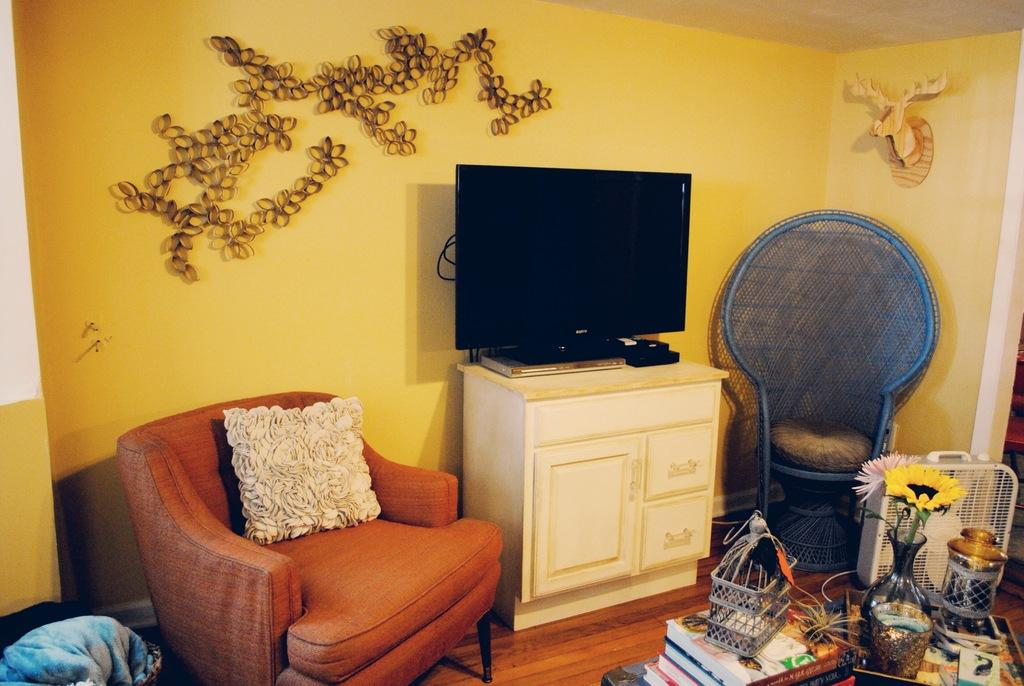What type of furniture is in the room? There is a sofa chair in the room. What type of entertainment device is in the room? There is a TV in the room. What can be found on the table in the room? There are books on a table in the room. How many tickets are visible on the table in the room? There are no tickets present on the table in the room. What type of belief system is represented by the items in the room? The provided facts do not give any information about a belief system, so it cannot be determined from the image. 